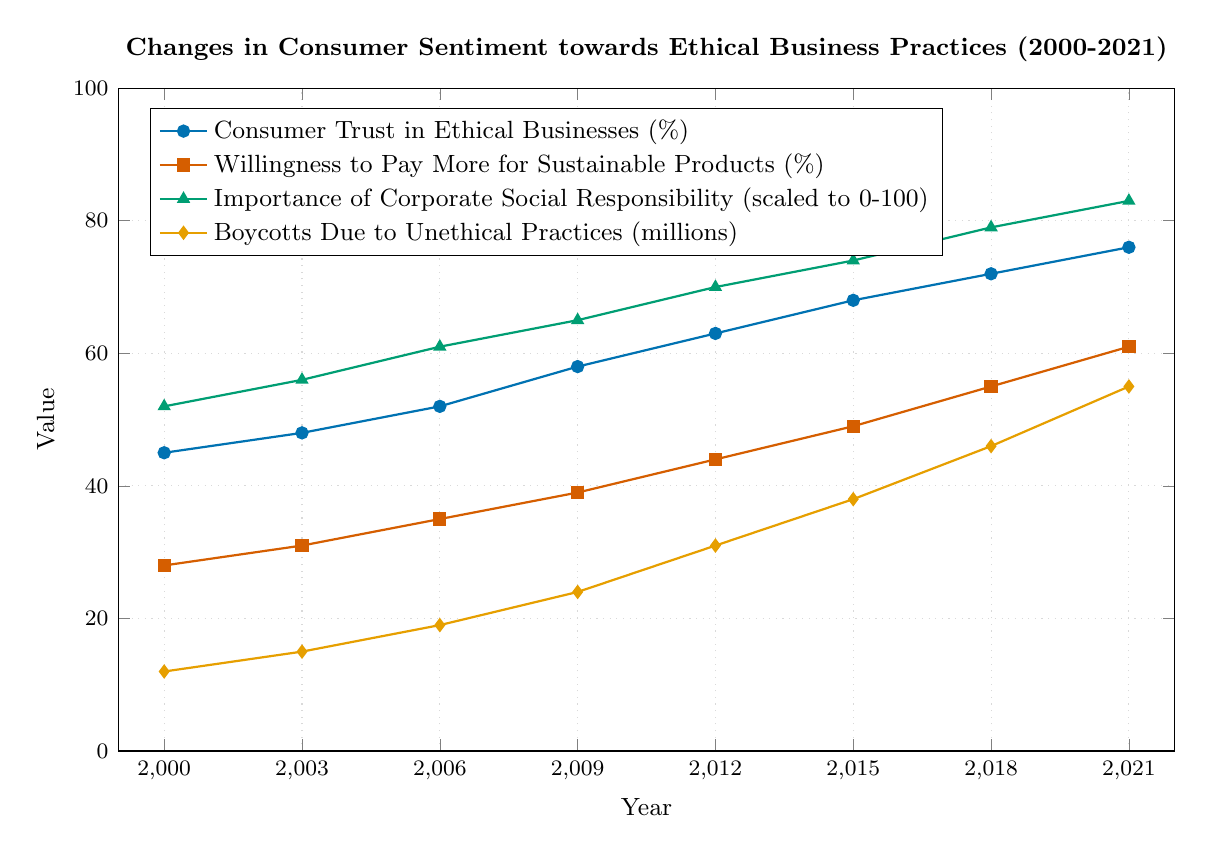What is the average Consumer Trust in Ethical Businesses (%) from 2000 to 2021? The values for Consumer Trust in Ethical Businesses (%) are (45, 48, 52, 58, 63, 68, 72, 76). To find the average, sum these values: 45 + 48 + 52 + 58 + 63 + 68 + 72 + 76 = 482. Then, divide by the number of years: 482 / 8 = 60.25
Answer: 60.25 Which year saw the highest Willingness to Pay More for Sustainable Products (%)? To identify the highest value, examine the data points over the years: (28, 31, 35, 39, 44, 49, 55, 61). The highest value is 61, which occurs in the year 2021
Answer: 2021 How many millions more Boycotts Due to Unethical Practices occurred in 2018 compared to 2000? Compare the values for boycotts: 2018 (46 million) and 2000 (12 million). The difference is calculated as 46 - 12 = 34 million
Answer: 34 In which year did the Importance of Corporate Social Responsibility reach 7.0? Look at the values for the Importance of Corporate Social Responsibility: (5.2, 5.6, 6.1, 6.5, 7.0, 7.4, 7.9, 8.3). The value 7.0 occurs in the year 2012
Answer: 2012 Has the Consumer Trust in Ethical Businesses (%) ever decreased between 2000 and 2021? Examine the trend of percentages over the years: (45, 48, 52, 58, 63, 68, 72, 76). All values show an increasing trend; hence, there is no decrease
Answer: No Compare the increase in Consumer Trust in Ethical Businesses (%) and the increase in Boycotts Due to Unethical Practices (millions) between 2000 and 2021 Calculate the increase for Consumer Trust: 76 - 45 = 31%. For boycotts, calculate: 55 - 12 = 43 million. The increase in boycotts is greater than in consumer trust
Answer: Boycotts increase more In which year did Willingness to Pay More for Sustainable Products (%) exceed 50% for the first time? Check the values over the years: (28, 31, 35, 39, 44, 49, 55, 61). The first value exceeding 50% is 55 in the year 2018
Answer: 2018 What is the difference between the Importance of Corporate Social Responsibility and Consumer Trust in Ethical Businesses (%) in 2009? From the data, Importance of Corporate Social Responsibility in 2009 is 6.5, and Consumer Trust in Ethical Businesses (%) is 58. Convert the Importance of Corporate Social Responsibility to the same scale (0-100): 6.5 * 10 = 65. The difference is 65 - 58 = 7
Answer: 7 What is the overall trend observed for Boycotts Due to Unethical Practices from 2000 to 2021? The values are (12, 15, 19, 24, 31, 38, 46, 55), showing a consistent increase in the number of boycotts over time
Answer: Increasing trend 